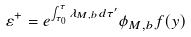Convert formula to latex. <formula><loc_0><loc_0><loc_500><loc_500>\varepsilon ^ { + } = e ^ { \int _ { \tau _ { 0 } } ^ { \tau } \lambda _ { M , b } d \tau ^ { \prime } } \phi _ { M , b } f ( y )</formula> 